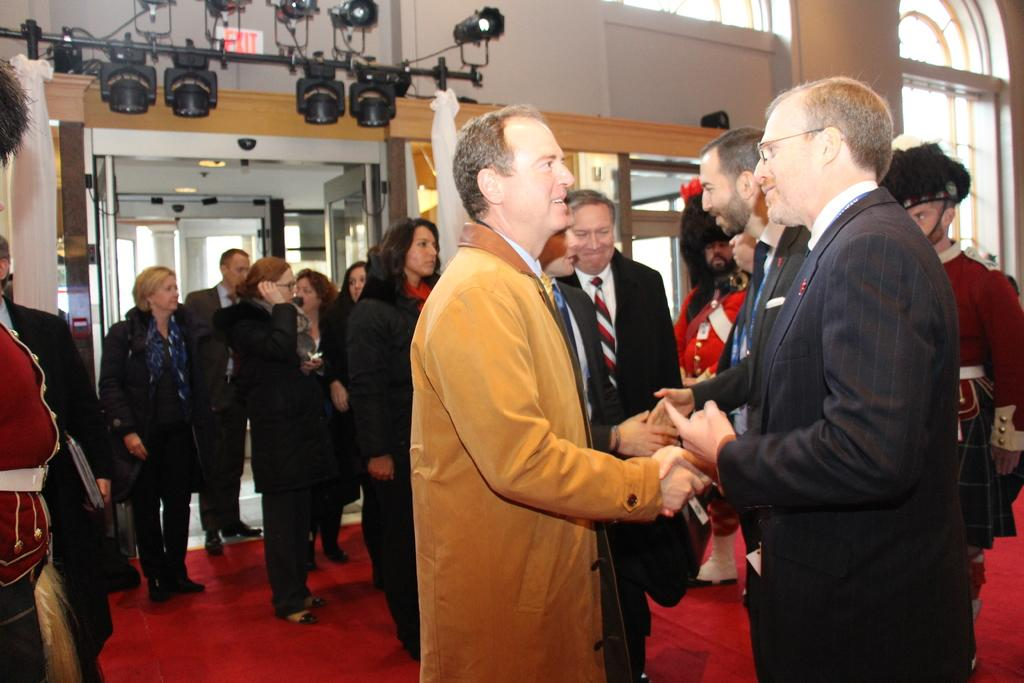How many people are present in the image? There are many people in the image. What can be seen in the background of the image? There is a stand with lights in the background. Are there any architectural features in the image? Yes, there are doors in the image. What are two persons wearing in the image? Two persons are wearing caps. What type of throat medicine is being advertised on the stand with lights in the image? There is no throat medicine or advertisement present in the image; it features a stand with lights in the background. How does the image capture the attention of the people in the image? The image does not capture the attention of the people in the image; it simply shows them in their current state. 